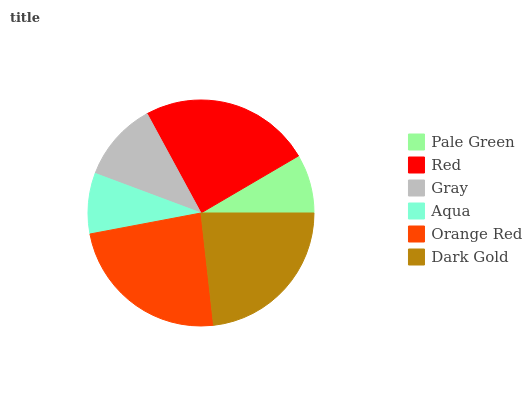Is Pale Green the minimum?
Answer yes or no. Yes. Is Red the maximum?
Answer yes or no. Yes. Is Gray the minimum?
Answer yes or no. No. Is Gray the maximum?
Answer yes or no. No. Is Red greater than Gray?
Answer yes or no. Yes. Is Gray less than Red?
Answer yes or no. Yes. Is Gray greater than Red?
Answer yes or no. No. Is Red less than Gray?
Answer yes or no. No. Is Dark Gold the high median?
Answer yes or no. Yes. Is Gray the low median?
Answer yes or no. Yes. Is Aqua the high median?
Answer yes or no. No. Is Pale Green the low median?
Answer yes or no. No. 